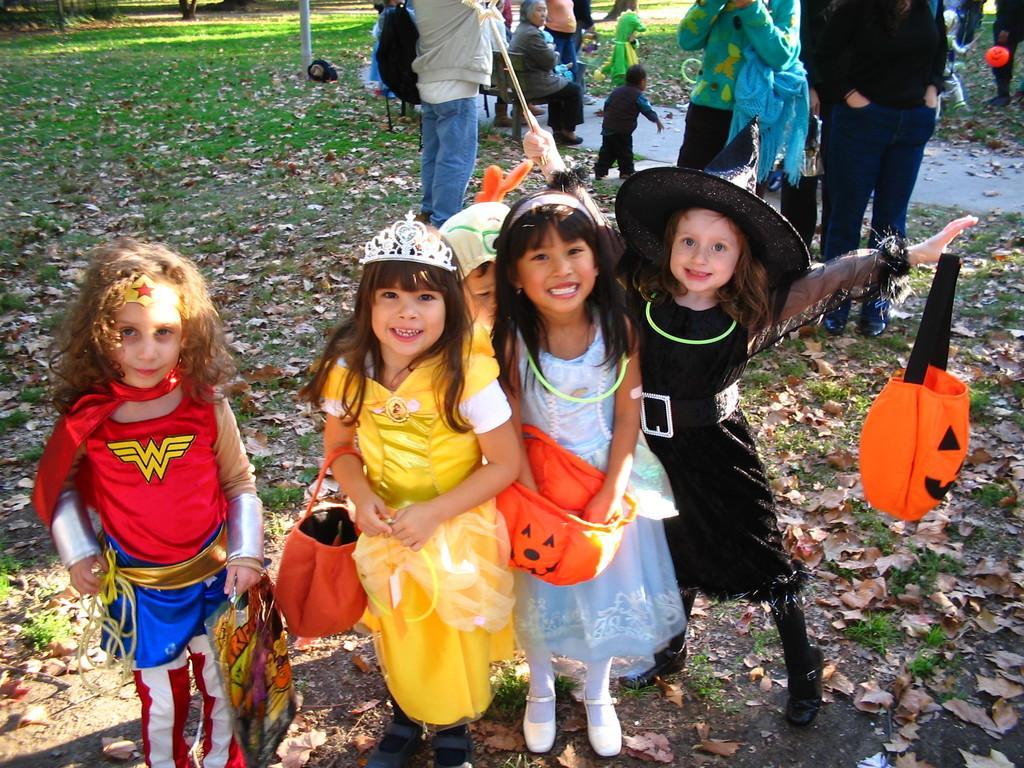Can you describe this image briefly? There are five girls standing as we can see at the bottom of this image, and there are some persons in the background. 